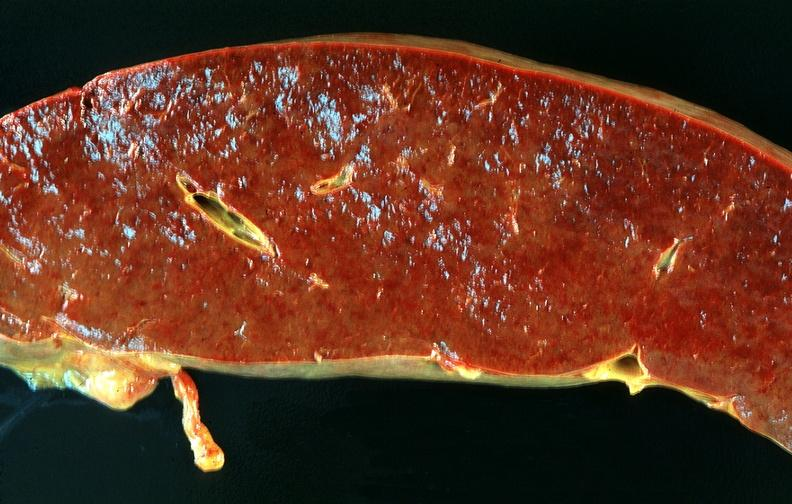where is this part in?
Answer the question using a single word or phrase. Spleen 